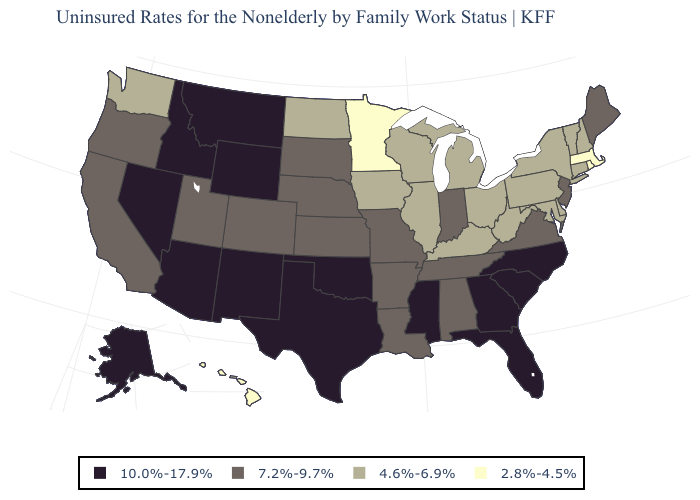What is the highest value in the West ?
Give a very brief answer. 10.0%-17.9%. Is the legend a continuous bar?
Answer briefly. No. Does California have the same value as Utah?
Be succinct. Yes. Name the states that have a value in the range 10.0%-17.9%?
Write a very short answer. Alaska, Arizona, Florida, Georgia, Idaho, Mississippi, Montana, Nevada, New Mexico, North Carolina, Oklahoma, South Carolina, Texas, Wyoming. Does Massachusetts have the same value as Hawaii?
Short answer required. Yes. Name the states that have a value in the range 10.0%-17.9%?
Quick response, please. Alaska, Arizona, Florida, Georgia, Idaho, Mississippi, Montana, Nevada, New Mexico, North Carolina, Oklahoma, South Carolina, Texas, Wyoming. What is the value of Alaska?
Keep it brief. 10.0%-17.9%. What is the lowest value in states that border Iowa?
Keep it brief. 2.8%-4.5%. Does Minnesota have a lower value than Hawaii?
Short answer required. No. What is the lowest value in the USA?
Concise answer only. 2.8%-4.5%. Which states have the highest value in the USA?
Concise answer only. Alaska, Arizona, Florida, Georgia, Idaho, Mississippi, Montana, Nevada, New Mexico, North Carolina, Oklahoma, South Carolina, Texas, Wyoming. Name the states that have a value in the range 4.6%-6.9%?
Be succinct. Connecticut, Delaware, Illinois, Iowa, Kentucky, Maryland, Michigan, New Hampshire, New York, North Dakota, Ohio, Pennsylvania, Vermont, Washington, West Virginia, Wisconsin. Does the map have missing data?
Give a very brief answer. No. How many symbols are there in the legend?
Quick response, please. 4. How many symbols are there in the legend?
Concise answer only. 4. 